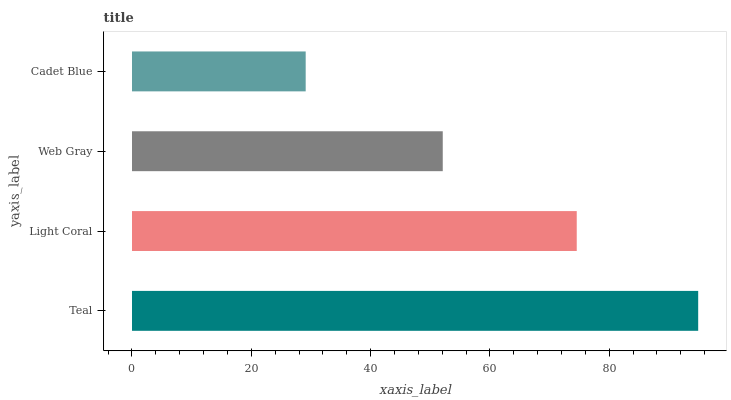Is Cadet Blue the minimum?
Answer yes or no. Yes. Is Teal the maximum?
Answer yes or no. Yes. Is Light Coral the minimum?
Answer yes or no. No. Is Light Coral the maximum?
Answer yes or no. No. Is Teal greater than Light Coral?
Answer yes or no. Yes. Is Light Coral less than Teal?
Answer yes or no. Yes. Is Light Coral greater than Teal?
Answer yes or no. No. Is Teal less than Light Coral?
Answer yes or no. No. Is Light Coral the high median?
Answer yes or no. Yes. Is Web Gray the low median?
Answer yes or no. Yes. Is Cadet Blue the high median?
Answer yes or no. No. Is Light Coral the low median?
Answer yes or no. No. 